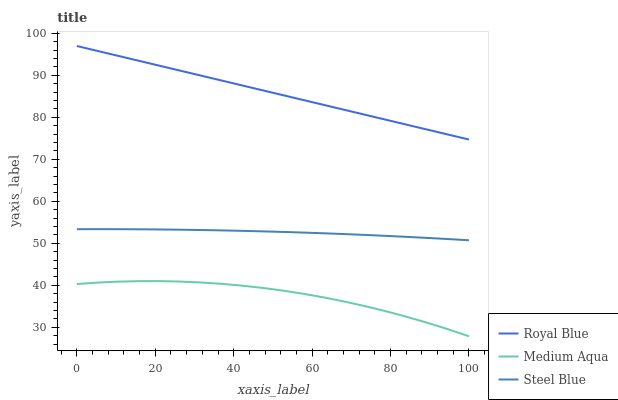Does Medium Aqua have the minimum area under the curve?
Answer yes or no. Yes. Does Royal Blue have the maximum area under the curve?
Answer yes or no. Yes. Does Steel Blue have the minimum area under the curve?
Answer yes or no. No. Does Steel Blue have the maximum area under the curve?
Answer yes or no. No. Is Royal Blue the smoothest?
Answer yes or no. Yes. Is Medium Aqua the roughest?
Answer yes or no. Yes. Is Steel Blue the smoothest?
Answer yes or no. No. Is Steel Blue the roughest?
Answer yes or no. No. Does Medium Aqua have the lowest value?
Answer yes or no. Yes. Does Steel Blue have the lowest value?
Answer yes or no. No. Does Royal Blue have the highest value?
Answer yes or no. Yes. Does Steel Blue have the highest value?
Answer yes or no. No. Is Steel Blue less than Royal Blue?
Answer yes or no. Yes. Is Steel Blue greater than Medium Aqua?
Answer yes or no. Yes. Does Steel Blue intersect Royal Blue?
Answer yes or no. No. 